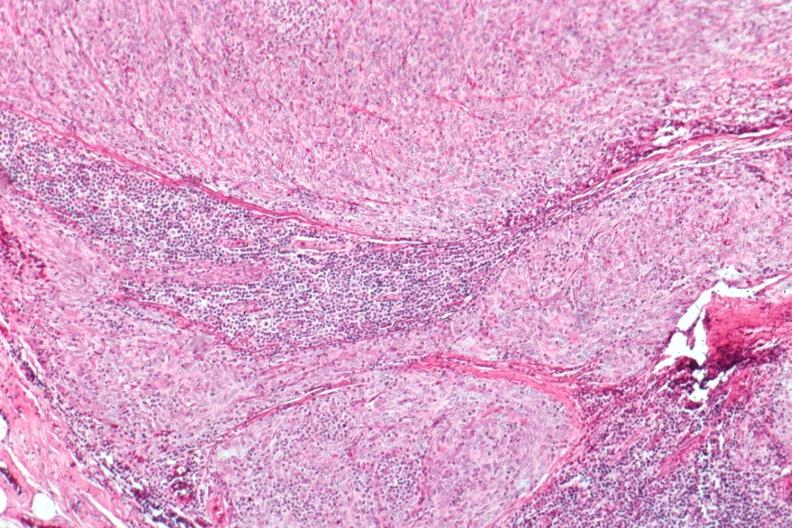what is present?
Answer the question using a single word or phrase. Hematologic 